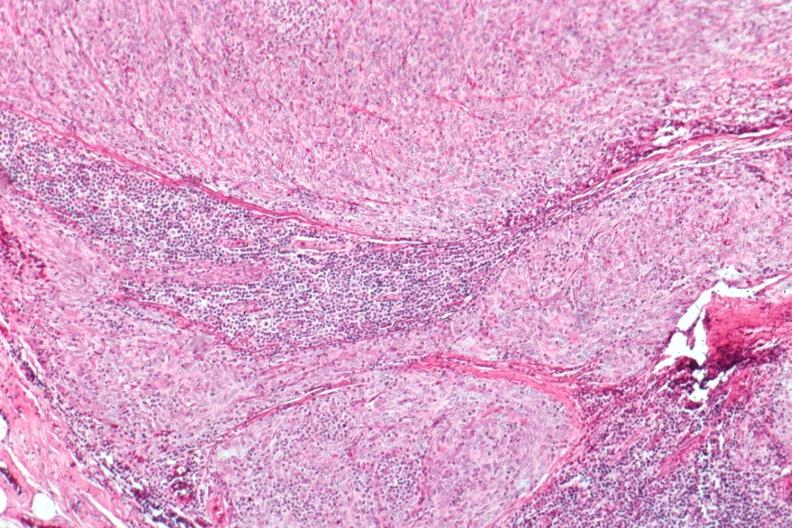what is present?
Answer the question using a single word or phrase. Hematologic 